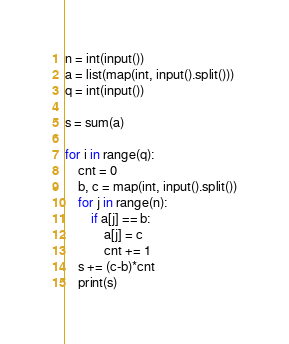<code> <loc_0><loc_0><loc_500><loc_500><_Python_>n = int(input())
a = list(map(int, input().split()))
q = int(input())

s = sum(a)

for i in range(q):
    cnt = 0
    b, c = map(int, input().split())
    for j in range(n):
        if a[j] == b:
            a[j] = c
            cnt += 1
    s += (c-b)*cnt
    print(s)</code> 